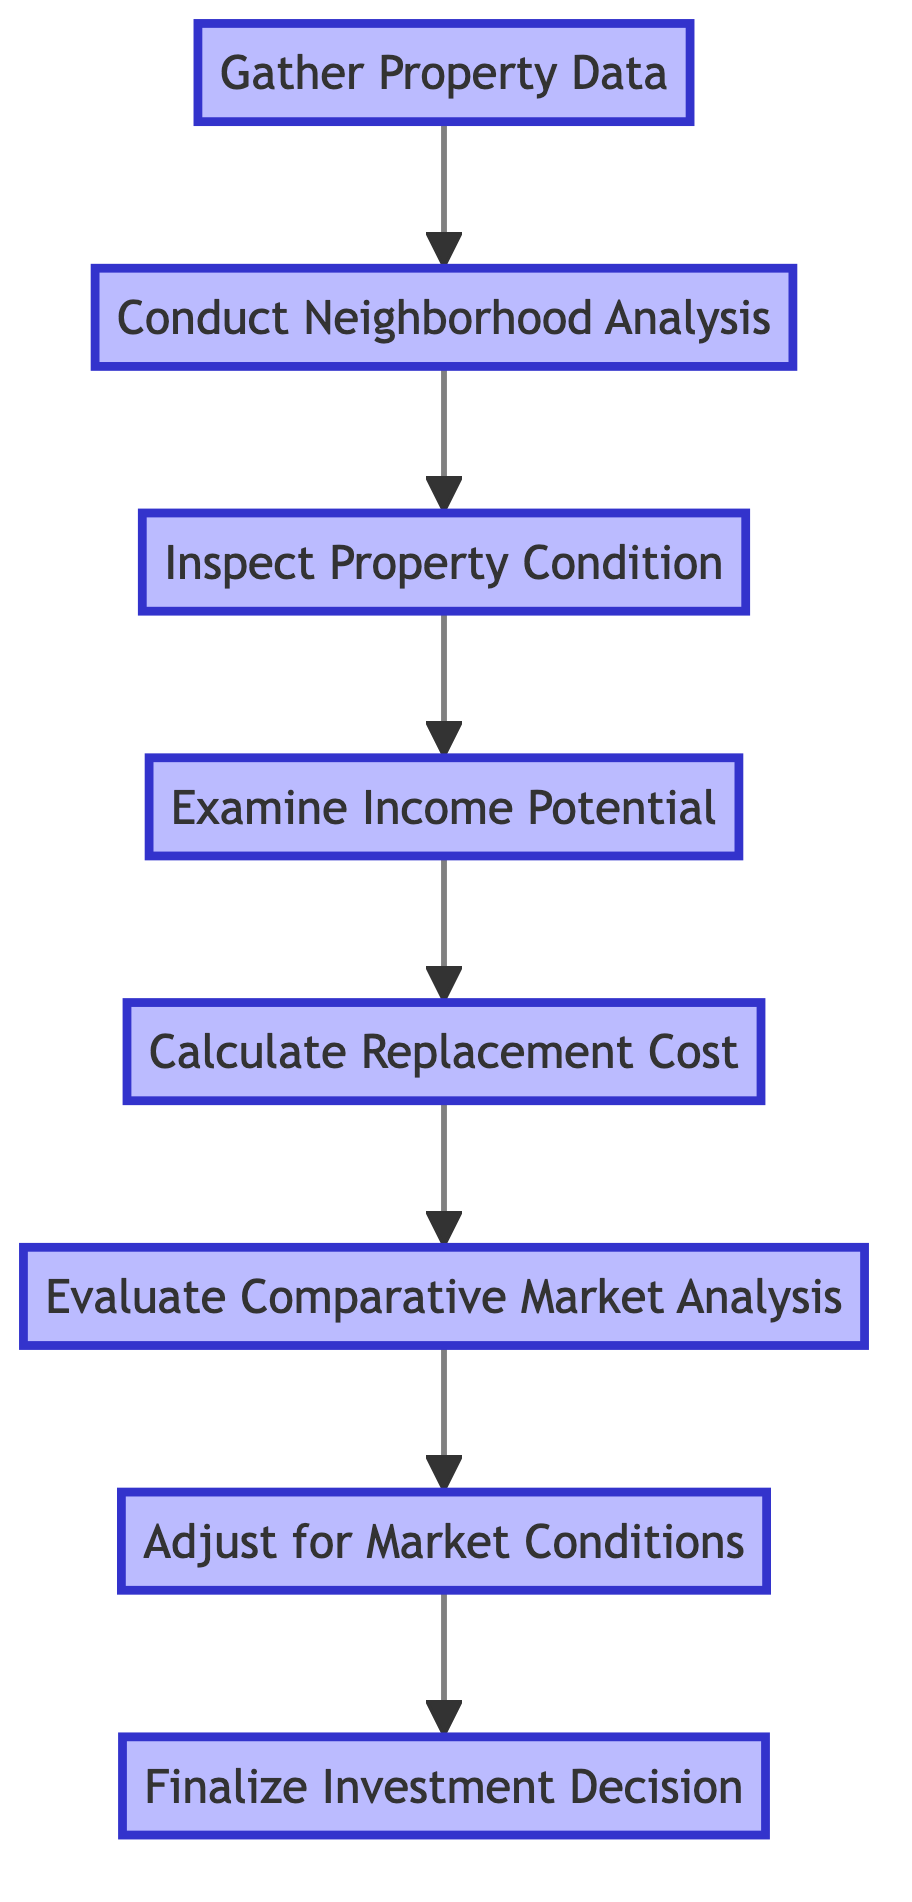What is the first step in determining property market value? The first step as per the diagram is to "Gather Property Data," which is the starting node in the flow.
Answer: Gather Property Data How many total steps are outlined in the diagram? By counting the nodes present in the diagram, we can see there are 8 steps in total.
Answer: 8 What is the last step in the flow? The last step in the process is "Finalize Investment Decision," as it is the final node that concludes the flow.
Answer: Finalize Investment Decision What follows after "Inspect Property Condition"? After "Inspect Property Condition," the next step is "Examine Income Potential," which continues the flow upwards.
Answer: Examine Income Potential Which step involves the assessment of the neighborhood? The step that involves an assessment of the neighborhood is "Conduct Neighborhood Analysis," occurring after gathering data and before inspecting the property.
Answer: Conduct Neighborhood Analysis What is the relationship between "Calculate Replacement Cost" and "Evaluate Comparative Market Analysis"? "Calculate Replacement Cost" directly precedes "Evaluate Comparative Market Analysis" in the flow, indicating that it is the step that comes before it.
Answer: Calculate Replacement Cost precedes Evaluate Comparative Market Analysis What must be evaluated before adjusting for market conditions? "Evaluate Comparative Market Analysis" must be evaluated before adjusting for market conditions, as it’s the immediate preceding step in the flow.
Answer: Evaluate Comparative Market Analysis What is the common purpose of all the steps in the flow? The common purpose of all the steps is to arrive at an accurate property market valuation, culminating in the investment decision.
Answer: Accurate property market valuation What two steps are directly connected to the property condition? The two steps directly connected to property condition are "Conduct Neighborhood Analysis" (before it) and "Examine Income Potential" (after it), reflecting the systematic approach in the evaluation process.
Answer: Conduct Neighborhood Analysis and Examine Income Potential 